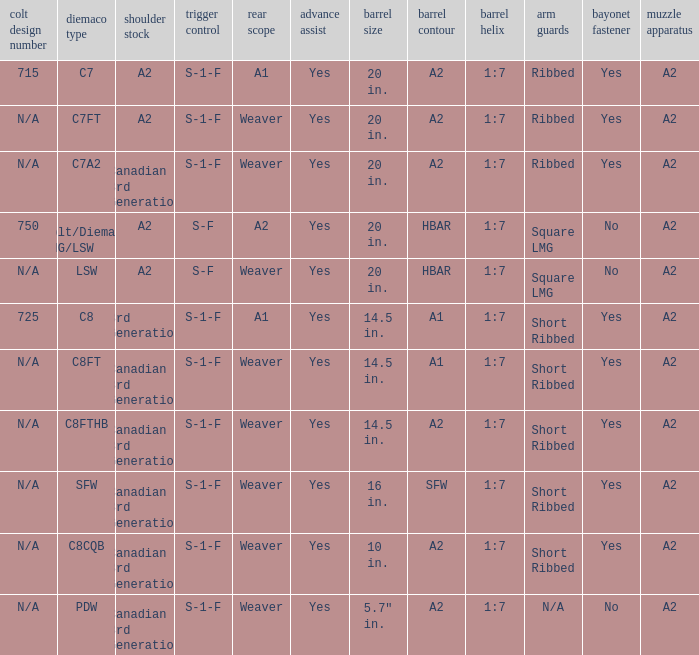Which Barrel twist has a Stock of canadian 3rd generation and a Hand guards of short ribbed? 1:7, 1:7, 1:7, 1:7. 